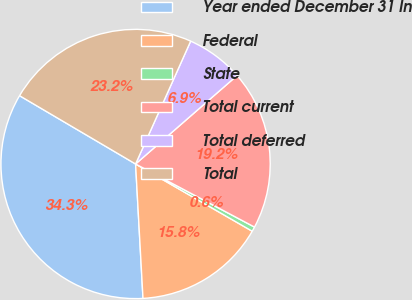Convert chart. <chart><loc_0><loc_0><loc_500><loc_500><pie_chart><fcel>Year ended December 31 In<fcel>Federal<fcel>State<fcel>Total current<fcel>Total deferred<fcel>Total<nl><fcel>34.34%<fcel>15.8%<fcel>0.56%<fcel>19.17%<fcel>6.88%<fcel>23.24%<nl></chart> 